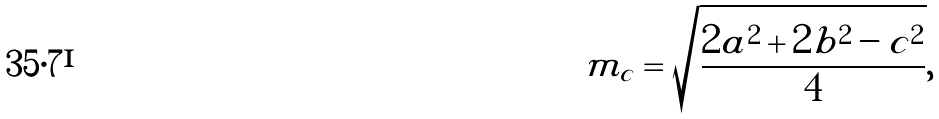<formula> <loc_0><loc_0><loc_500><loc_500>m _ { c } = { \sqrt { \frac { 2 a ^ { 2 } + 2 b ^ { 2 } - c ^ { 2 } } { 4 } } } ,</formula> 